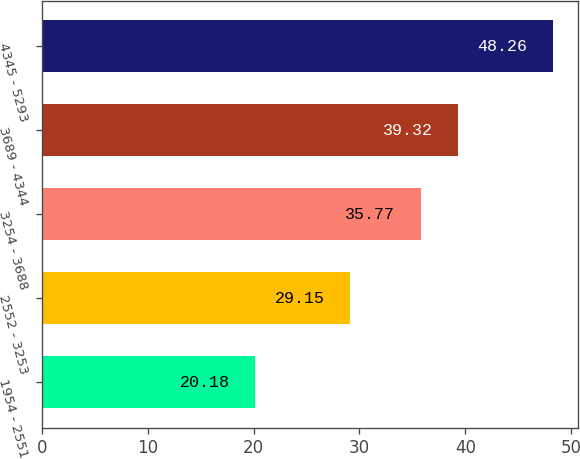<chart> <loc_0><loc_0><loc_500><loc_500><bar_chart><fcel>1954 - 2551<fcel>2552 - 3253<fcel>3254 - 3688<fcel>3689 - 4344<fcel>4345 - 5293<nl><fcel>20.18<fcel>29.15<fcel>35.77<fcel>39.32<fcel>48.26<nl></chart> 